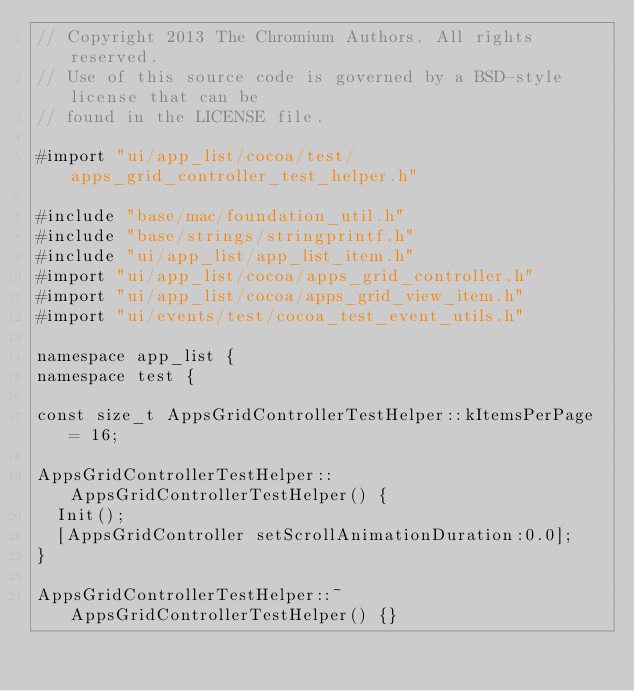Convert code to text. <code><loc_0><loc_0><loc_500><loc_500><_ObjectiveC_>// Copyright 2013 The Chromium Authors. All rights reserved.
// Use of this source code is governed by a BSD-style license that can be
// found in the LICENSE file.

#import "ui/app_list/cocoa/test/apps_grid_controller_test_helper.h"

#include "base/mac/foundation_util.h"
#include "base/strings/stringprintf.h"
#include "ui/app_list/app_list_item.h"
#import "ui/app_list/cocoa/apps_grid_controller.h"
#import "ui/app_list/cocoa/apps_grid_view_item.h"
#import "ui/events/test/cocoa_test_event_utils.h"

namespace app_list {
namespace test {

const size_t AppsGridControllerTestHelper::kItemsPerPage = 16;

AppsGridControllerTestHelper::AppsGridControllerTestHelper() {
  Init();
  [AppsGridController setScrollAnimationDuration:0.0];
}

AppsGridControllerTestHelper::~AppsGridControllerTestHelper() {}
</code> 